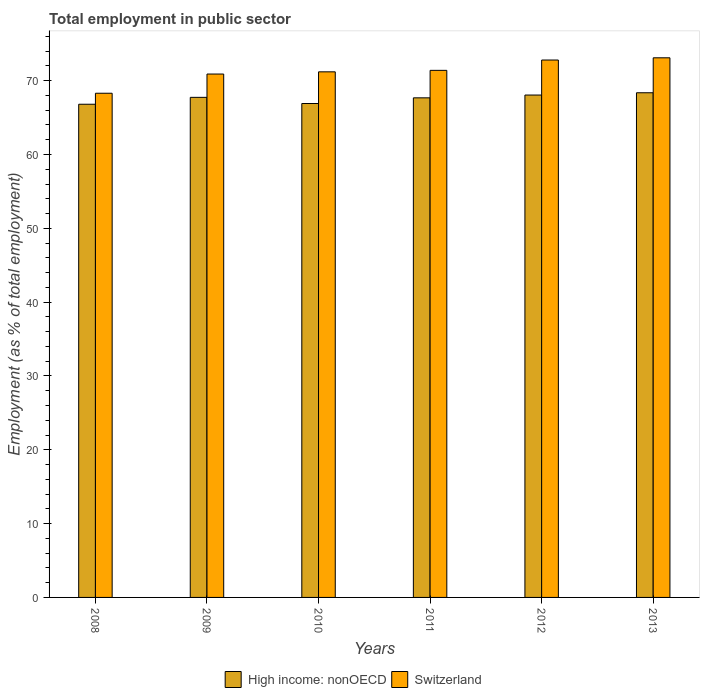Are the number of bars per tick equal to the number of legend labels?
Your answer should be compact. Yes. Are the number of bars on each tick of the X-axis equal?
Your response must be concise. Yes. What is the employment in public sector in Switzerland in 2011?
Provide a short and direct response. 71.4. Across all years, what is the maximum employment in public sector in Switzerland?
Offer a terse response. 73.1. Across all years, what is the minimum employment in public sector in High income: nonOECD?
Provide a short and direct response. 66.81. In which year was the employment in public sector in Switzerland maximum?
Keep it short and to the point. 2013. What is the total employment in public sector in Switzerland in the graph?
Offer a very short reply. 427.7. What is the difference between the employment in public sector in Switzerland in 2010 and that in 2012?
Ensure brevity in your answer.  -1.6. What is the difference between the employment in public sector in Switzerland in 2011 and the employment in public sector in High income: nonOECD in 2009?
Your answer should be compact. 3.66. What is the average employment in public sector in High income: nonOECD per year?
Offer a very short reply. 67.59. In the year 2012, what is the difference between the employment in public sector in High income: nonOECD and employment in public sector in Switzerland?
Offer a terse response. -4.74. In how many years, is the employment in public sector in Switzerland greater than 24 %?
Keep it short and to the point. 6. What is the ratio of the employment in public sector in Switzerland in 2011 to that in 2012?
Make the answer very short. 0.98. What is the difference between the highest and the second highest employment in public sector in Switzerland?
Ensure brevity in your answer.  0.3. What is the difference between the highest and the lowest employment in public sector in High income: nonOECD?
Make the answer very short. 1.56. In how many years, is the employment in public sector in High income: nonOECD greater than the average employment in public sector in High income: nonOECD taken over all years?
Make the answer very short. 4. What does the 1st bar from the left in 2010 represents?
Your answer should be very brief. High income: nonOECD. What does the 1st bar from the right in 2009 represents?
Provide a succinct answer. Switzerland. How many years are there in the graph?
Your answer should be compact. 6. Where does the legend appear in the graph?
Offer a terse response. Bottom center. How many legend labels are there?
Give a very brief answer. 2. What is the title of the graph?
Provide a short and direct response. Total employment in public sector. What is the label or title of the X-axis?
Give a very brief answer. Years. What is the label or title of the Y-axis?
Keep it short and to the point. Employment (as % of total employment). What is the Employment (as % of total employment) in High income: nonOECD in 2008?
Provide a succinct answer. 66.81. What is the Employment (as % of total employment) in Switzerland in 2008?
Your answer should be very brief. 68.3. What is the Employment (as % of total employment) in High income: nonOECD in 2009?
Offer a terse response. 67.74. What is the Employment (as % of total employment) in Switzerland in 2009?
Keep it short and to the point. 70.9. What is the Employment (as % of total employment) of High income: nonOECD in 2010?
Give a very brief answer. 66.91. What is the Employment (as % of total employment) of Switzerland in 2010?
Your answer should be compact. 71.2. What is the Employment (as % of total employment) in High income: nonOECD in 2011?
Give a very brief answer. 67.68. What is the Employment (as % of total employment) in Switzerland in 2011?
Offer a very short reply. 71.4. What is the Employment (as % of total employment) of High income: nonOECD in 2012?
Make the answer very short. 68.06. What is the Employment (as % of total employment) in Switzerland in 2012?
Ensure brevity in your answer.  72.8. What is the Employment (as % of total employment) in High income: nonOECD in 2013?
Your answer should be very brief. 68.37. What is the Employment (as % of total employment) in Switzerland in 2013?
Offer a terse response. 73.1. Across all years, what is the maximum Employment (as % of total employment) of High income: nonOECD?
Provide a succinct answer. 68.37. Across all years, what is the maximum Employment (as % of total employment) of Switzerland?
Your answer should be compact. 73.1. Across all years, what is the minimum Employment (as % of total employment) of High income: nonOECD?
Ensure brevity in your answer.  66.81. Across all years, what is the minimum Employment (as % of total employment) in Switzerland?
Keep it short and to the point. 68.3. What is the total Employment (as % of total employment) in High income: nonOECD in the graph?
Offer a very short reply. 405.56. What is the total Employment (as % of total employment) of Switzerland in the graph?
Ensure brevity in your answer.  427.7. What is the difference between the Employment (as % of total employment) of High income: nonOECD in 2008 and that in 2009?
Keep it short and to the point. -0.93. What is the difference between the Employment (as % of total employment) in Switzerland in 2008 and that in 2009?
Your response must be concise. -2.6. What is the difference between the Employment (as % of total employment) in High income: nonOECD in 2008 and that in 2010?
Make the answer very short. -0.1. What is the difference between the Employment (as % of total employment) in Switzerland in 2008 and that in 2010?
Give a very brief answer. -2.9. What is the difference between the Employment (as % of total employment) of High income: nonOECD in 2008 and that in 2011?
Ensure brevity in your answer.  -0.87. What is the difference between the Employment (as % of total employment) in High income: nonOECD in 2008 and that in 2012?
Provide a succinct answer. -1.25. What is the difference between the Employment (as % of total employment) in High income: nonOECD in 2008 and that in 2013?
Make the answer very short. -1.56. What is the difference between the Employment (as % of total employment) of High income: nonOECD in 2009 and that in 2010?
Make the answer very short. 0.83. What is the difference between the Employment (as % of total employment) of High income: nonOECD in 2009 and that in 2011?
Your answer should be compact. 0.07. What is the difference between the Employment (as % of total employment) in High income: nonOECD in 2009 and that in 2012?
Provide a short and direct response. -0.31. What is the difference between the Employment (as % of total employment) in Switzerland in 2009 and that in 2012?
Offer a terse response. -1.9. What is the difference between the Employment (as % of total employment) in High income: nonOECD in 2009 and that in 2013?
Ensure brevity in your answer.  -0.62. What is the difference between the Employment (as % of total employment) in Switzerland in 2009 and that in 2013?
Keep it short and to the point. -2.2. What is the difference between the Employment (as % of total employment) of High income: nonOECD in 2010 and that in 2011?
Provide a succinct answer. -0.77. What is the difference between the Employment (as % of total employment) in Switzerland in 2010 and that in 2011?
Your answer should be very brief. -0.2. What is the difference between the Employment (as % of total employment) of High income: nonOECD in 2010 and that in 2012?
Offer a terse response. -1.15. What is the difference between the Employment (as % of total employment) of Switzerland in 2010 and that in 2012?
Ensure brevity in your answer.  -1.6. What is the difference between the Employment (as % of total employment) in High income: nonOECD in 2010 and that in 2013?
Make the answer very short. -1.46. What is the difference between the Employment (as % of total employment) of High income: nonOECD in 2011 and that in 2012?
Keep it short and to the point. -0.38. What is the difference between the Employment (as % of total employment) in Switzerland in 2011 and that in 2012?
Provide a short and direct response. -1.4. What is the difference between the Employment (as % of total employment) in High income: nonOECD in 2011 and that in 2013?
Provide a short and direct response. -0.69. What is the difference between the Employment (as % of total employment) in High income: nonOECD in 2012 and that in 2013?
Offer a very short reply. -0.31. What is the difference between the Employment (as % of total employment) in Switzerland in 2012 and that in 2013?
Give a very brief answer. -0.3. What is the difference between the Employment (as % of total employment) in High income: nonOECD in 2008 and the Employment (as % of total employment) in Switzerland in 2009?
Offer a terse response. -4.09. What is the difference between the Employment (as % of total employment) of High income: nonOECD in 2008 and the Employment (as % of total employment) of Switzerland in 2010?
Your answer should be very brief. -4.39. What is the difference between the Employment (as % of total employment) in High income: nonOECD in 2008 and the Employment (as % of total employment) in Switzerland in 2011?
Offer a very short reply. -4.59. What is the difference between the Employment (as % of total employment) of High income: nonOECD in 2008 and the Employment (as % of total employment) of Switzerland in 2012?
Offer a terse response. -5.99. What is the difference between the Employment (as % of total employment) of High income: nonOECD in 2008 and the Employment (as % of total employment) of Switzerland in 2013?
Keep it short and to the point. -6.29. What is the difference between the Employment (as % of total employment) in High income: nonOECD in 2009 and the Employment (as % of total employment) in Switzerland in 2010?
Keep it short and to the point. -3.46. What is the difference between the Employment (as % of total employment) of High income: nonOECD in 2009 and the Employment (as % of total employment) of Switzerland in 2011?
Provide a succinct answer. -3.66. What is the difference between the Employment (as % of total employment) of High income: nonOECD in 2009 and the Employment (as % of total employment) of Switzerland in 2012?
Your answer should be very brief. -5.06. What is the difference between the Employment (as % of total employment) in High income: nonOECD in 2009 and the Employment (as % of total employment) in Switzerland in 2013?
Provide a succinct answer. -5.36. What is the difference between the Employment (as % of total employment) in High income: nonOECD in 2010 and the Employment (as % of total employment) in Switzerland in 2011?
Keep it short and to the point. -4.49. What is the difference between the Employment (as % of total employment) of High income: nonOECD in 2010 and the Employment (as % of total employment) of Switzerland in 2012?
Offer a very short reply. -5.89. What is the difference between the Employment (as % of total employment) of High income: nonOECD in 2010 and the Employment (as % of total employment) of Switzerland in 2013?
Give a very brief answer. -6.19. What is the difference between the Employment (as % of total employment) in High income: nonOECD in 2011 and the Employment (as % of total employment) in Switzerland in 2012?
Keep it short and to the point. -5.12. What is the difference between the Employment (as % of total employment) of High income: nonOECD in 2011 and the Employment (as % of total employment) of Switzerland in 2013?
Ensure brevity in your answer.  -5.42. What is the difference between the Employment (as % of total employment) of High income: nonOECD in 2012 and the Employment (as % of total employment) of Switzerland in 2013?
Provide a short and direct response. -5.04. What is the average Employment (as % of total employment) of High income: nonOECD per year?
Provide a short and direct response. 67.59. What is the average Employment (as % of total employment) in Switzerland per year?
Provide a succinct answer. 71.28. In the year 2008, what is the difference between the Employment (as % of total employment) of High income: nonOECD and Employment (as % of total employment) of Switzerland?
Make the answer very short. -1.49. In the year 2009, what is the difference between the Employment (as % of total employment) of High income: nonOECD and Employment (as % of total employment) of Switzerland?
Ensure brevity in your answer.  -3.16. In the year 2010, what is the difference between the Employment (as % of total employment) of High income: nonOECD and Employment (as % of total employment) of Switzerland?
Your answer should be compact. -4.29. In the year 2011, what is the difference between the Employment (as % of total employment) of High income: nonOECD and Employment (as % of total employment) of Switzerland?
Your answer should be compact. -3.72. In the year 2012, what is the difference between the Employment (as % of total employment) of High income: nonOECD and Employment (as % of total employment) of Switzerland?
Make the answer very short. -4.74. In the year 2013, what is the difference between the Employment (as % of total employment) in High income: nonOECD and Employment (as % of total employment) in Switzerland?
Provide a succinct answer. -4.73. What is the ratio of the Employment (as % of total employment) of High income: nonOECD in 2008 to that in 2009?
Provide a short and direct response. 0.99. What is the ratio of the Employment (as % of total employment) of Switzerland in 2008 to that in 2009?
Your answer should be compact. 0.96. What is the ratio of the Employment (as % of total employment) of Switzerland in 2008 to that in 2010?
Ensure brevity in your answer.  0.96. What is the ratio of the Employment (as % of total employment) in High income: nonOECD in 2008 to that in 2011?
Keep it short and to the point. 0.99. What is the ratio of the Employment (as % of total employment) of Switzerland in 2008 to that in 2011?
Make the answer very short. 0.96. What is the ratio of the Employment (as % of total employment) of High income: nonOECD in 2008 to that in 2012?
Ensure brevity in your answer.  0.98. What is the ratio of the Employment (as % of total employment) in Switzerland in 2008 to that in 2012?
Provide a short and direct response. 0.94. What is the ratio of the Employment (as % of total employment) in High income: nonOECD in 2008 to that in 2013?
Give a very brief answer. 0.98. What is the ratio of the Employment (as % of total employment) of Switzerland in 2008 to that in 2013?
Your answer should be very brief. 0.93. What is the ratio of the Employment (as % of total employment) in High income: nonOECD in 2009 to that in 2010?
Provide a succinct answer. 1.01. What is the ratio of the Employment (as % of total employment) of High income: nonOECD in 2009 to that in 2011?
Provide a succinct answer. 1. What is the ratio of the Employment (as % of total employment) in High income: nonOECD in 2009 to that in 2012?
Your answer should be compact. 1. What is the ratio of the Employment (as % of total employment) of Switzerland in 2009 to that in 2012?
Your answer should be very brief. 0.97. What is the ratio of the Employment (as % of total employment) of High income: nonOECD in 2009 to that in 2013?
Your response must be concise. 0.99. What is the ratio of the Employment (as % of total employment) in Switzerland in 2009 to that in 2013?
Give a very brief answer. 0.97. What is the ratio of the Employment (as % of total employment) in High income: nonOECD in 2010 to that in 2011?
Make the answer very short. 0.99. What is the ratio of the Employment (as % of total employment) of High income: nonOECD in 2010 to that in 2012?
Your answer should be compact. 0.98. What is the ratio of the Employment (as % of total employment) in Switzerland in 2010 to that in 2012?
Keep it short and to the point. 0.98. What is the ratio of the Employment (as % of total employment) of High income: nonOECD in 2010 to that in 2013?
Provide a succinct answer. 0.98. What is the ratio of the Employment (as % of total employment) of Switzerland in 2010 to that in 2013?
Provide a short and direct response. 0.97. What is the ratio of the Employment (as % of total employment) of High income: nonOECD in 2011 to that in 2012?
Ensure brevity in your answer.  0.99. What is the ratio of the Employment (as % of total employment) of Switzerland in 2011 to that in 2012?
Make the answer very short. 0.98. What is the ratio of the Employment (as % of total employment) of Switzerland in 2011 to that in 2013?
Provide a succinct answer. 0.98. What is the ratio of the Employment (as % of total employment) in Switzerland in 2012 to that in 2013?
Offer a very short reply. 1. What is the difference between the highest and the second highest Employment (as % of total employment) in High income: nonOECD?
Provide a short and direct response. 0.31. What is the difference between the highest and the lowest Employment (as % of total employment) of High income: nonOECD?
Offer a very short reply. 1.56. 